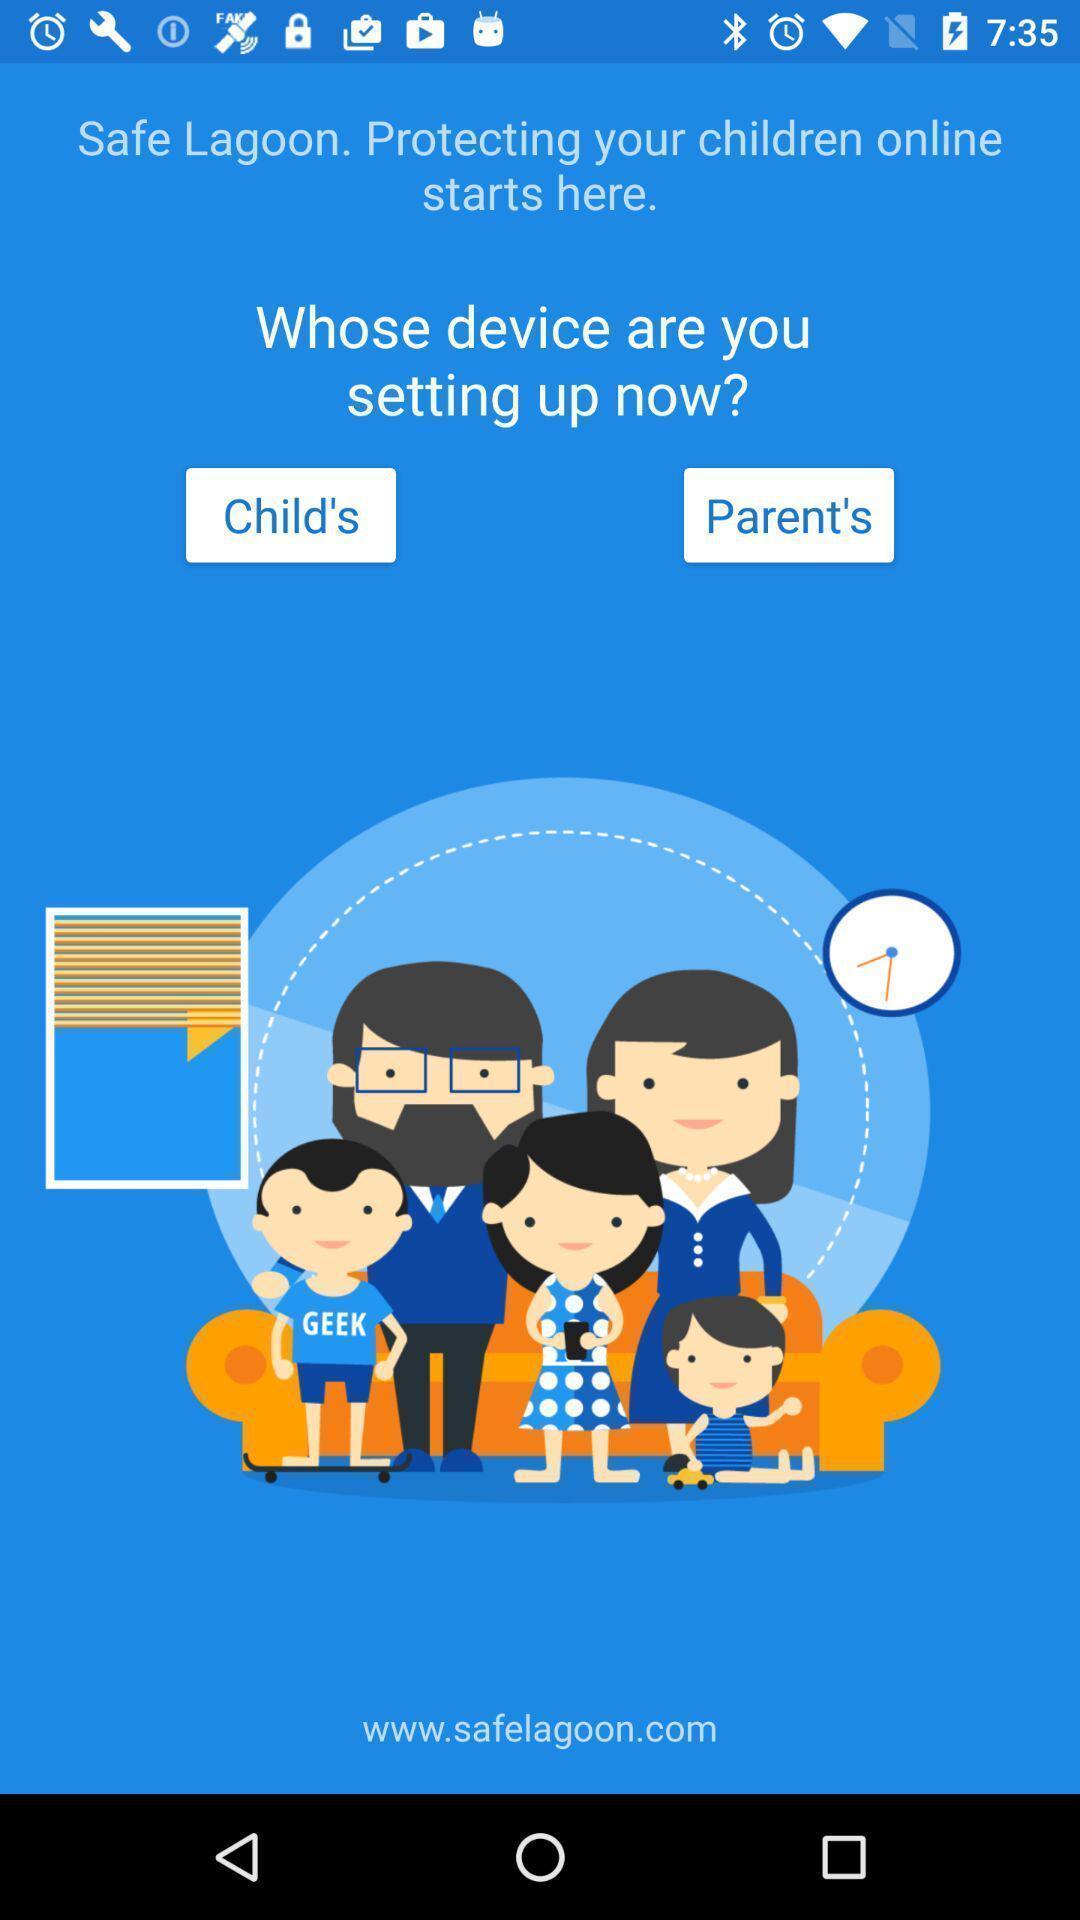Explain what's happening in this screen capture. User selection setup page in a family protection app. 